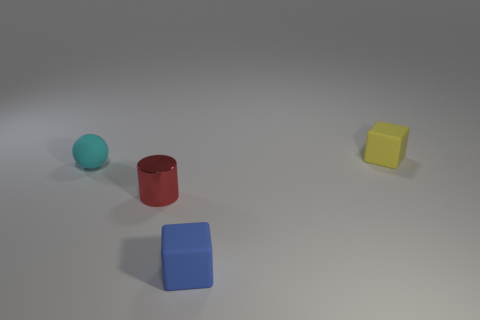Add 3 large rubber balls. How many objects exist? 7 Subtract all cylinders. How many objects are left? 3 Subtract 0 blue cylinders. How many objects are left? 4 Subtract all tiny red metallic objects. Subtract all small yellow rubber objects. How many objects are left? 2 Add 1 small cyan rubber balls. How many small cyan rubber balls are left? 2 Add 4 yellow matte blocks. How many yellow matte blocks exist? 5 